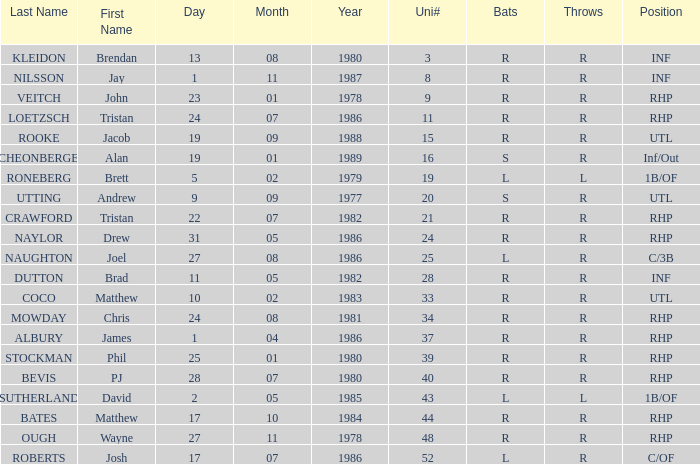Which First has a Uni # larger than 34, and Throws of r, and a Position of rhp, and a Surname of stockman? Phil. 